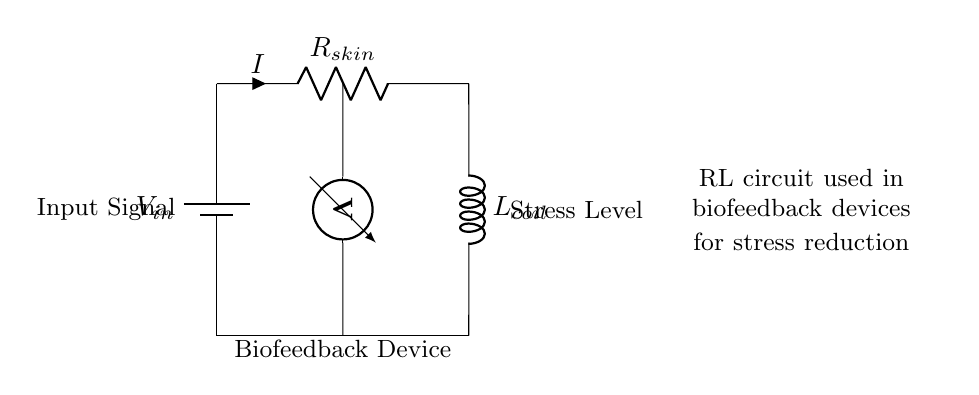What does the circuit represent? The circuit represents a biofeedback device used for stress reduction, indicated by the descriptive labeling in the diagram.
Answer: Biofeedback device What component measures the voltage in the circuit? The circuit diagram includes a voltmeter, which is represented visually between the input and ground connections.
Answer: Voltmeter What type of circuit is shown in the diagram? The circuit consists of a resistor and an inductor, indicating it is an RL circuit, as denoted by the labels in the drawing.
Answer: RL circuit What is the function of the resistor in this circuit? The resistor's role is to limit the current flowing through the skin resistance, affecting the overall response of the biofeedback device.
Answer: Limit current How does the inductor affect the behavior of the circuit over time? The inductor stores energy in a magnetic field when current flows through it, causing a delay (inductive time constant) in current changes, which is crucial for biofeedback applications in stress management.
Answer: Delays current changes What is the relationship between the stress level and the circuit's output? The stress level is visually indicated in the circuit; the output response (voltage/current) is related to the physiological signals measured, affected by resistance and inductance in the RL circuit.
Answer: Related to physiological signals What does "R_skin" indicate in this circuit? "R_skin" represents the resistance of the skin, which is a critical parameter that reflects physiological changes during stress and is involved in the biofeedback mechanism.
Answer: Skin resistance 